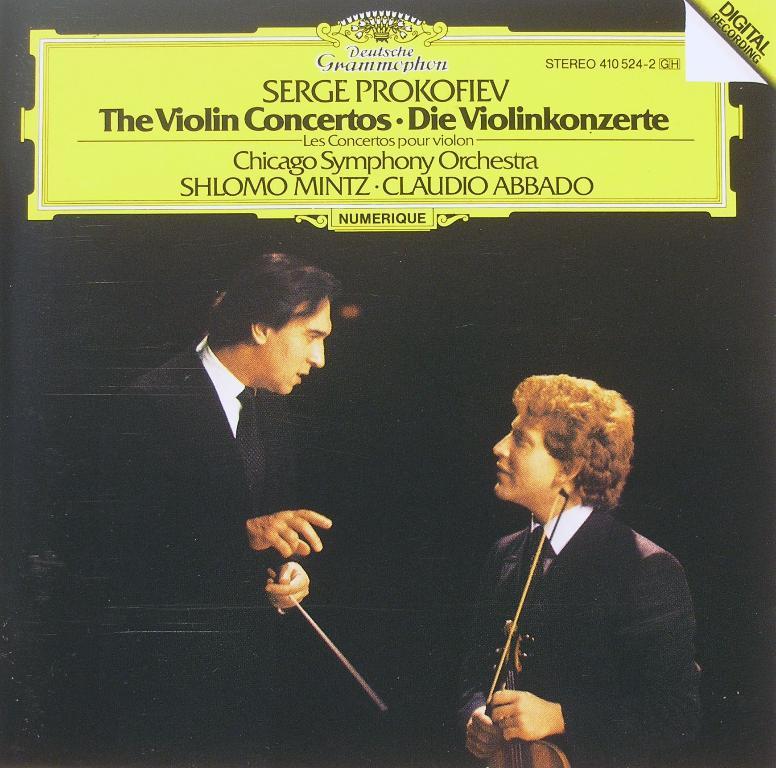Describe this image in one or two sentences. In this picture we can see a poster, there are two men in the front, a man on the right side is holding a violin, there is some text at the top of the picture. 